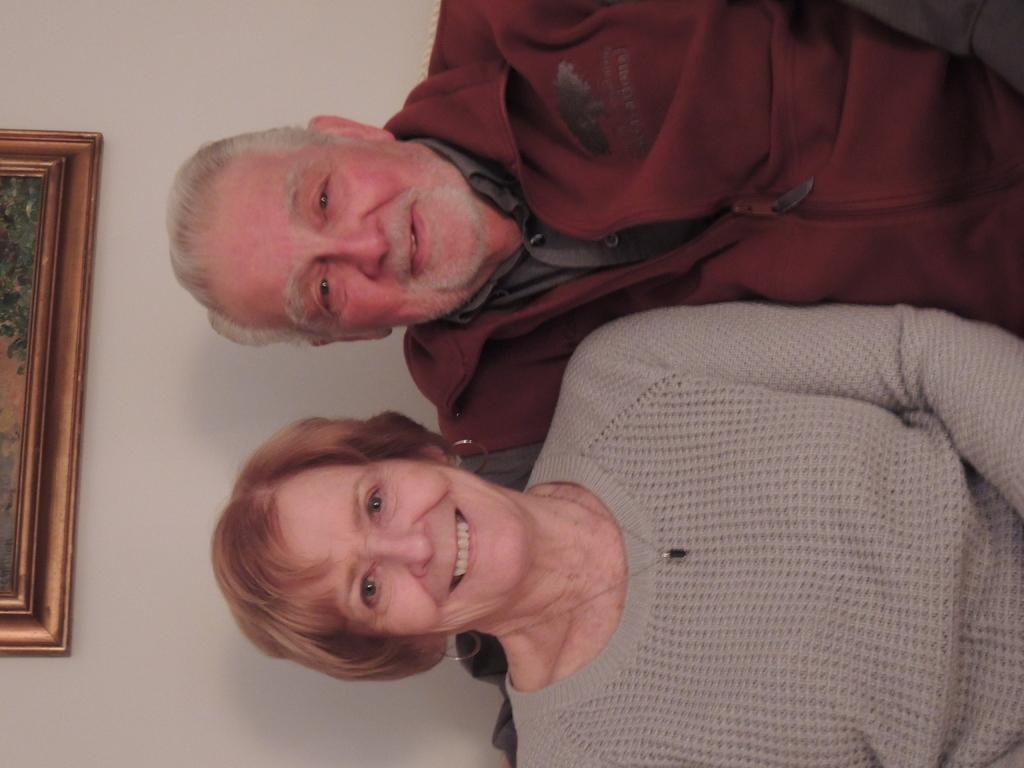In one or two sentences, can you explain what this image depicts? This picture is facing towards the left. In the picture, there is a woman and a man. Woman is wearing a grey sweater and woman is wearing a maroon jacket. On the top, there is a wall with a frame. 